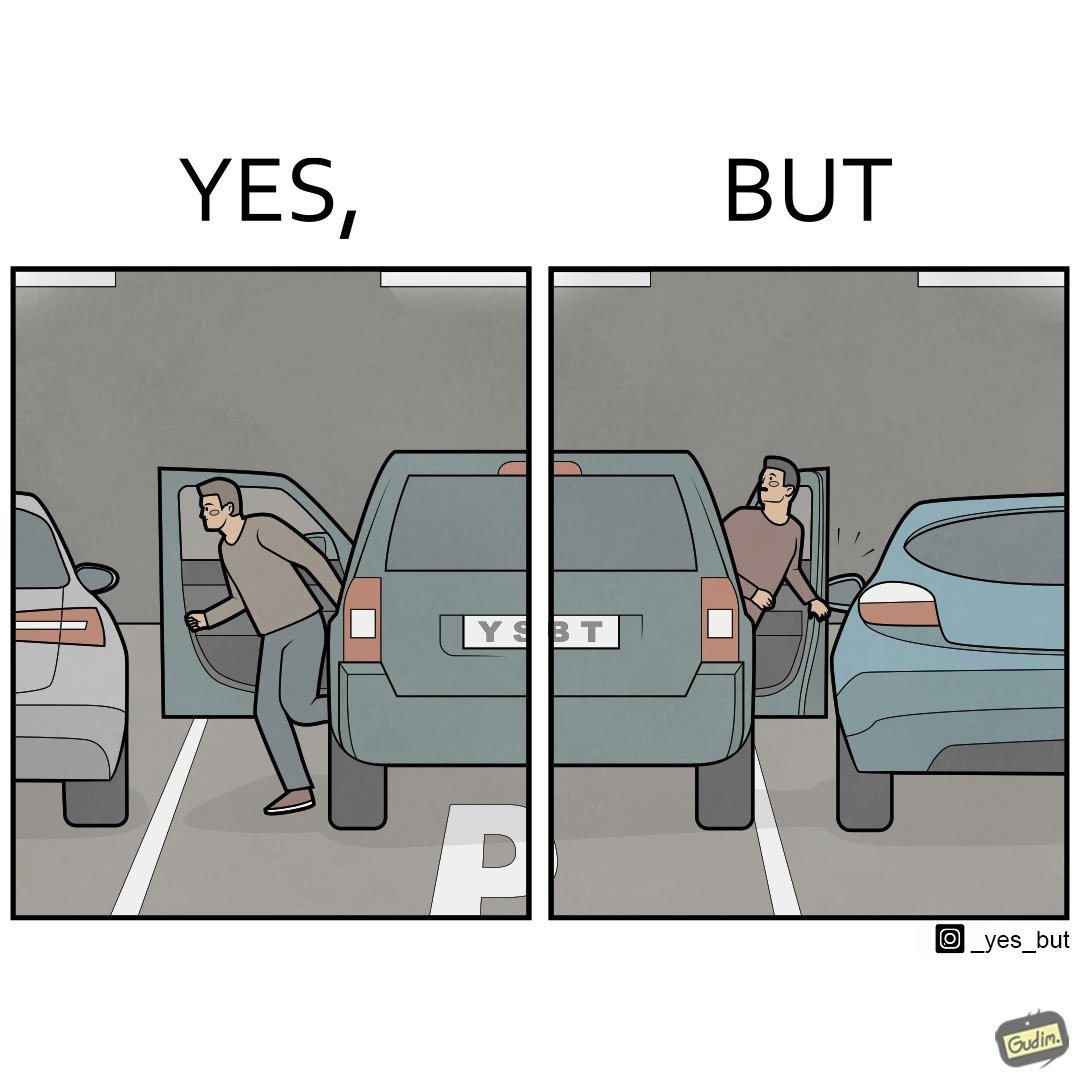Describe the content of this image. The image is ironic, because the left door of the car is easily opened with still space left so the car could have been parked more on the left whereas the right door of the car is getting stuck due to the less space between the two cars and the person in facing difficulty in getting himself out but person on the left easily gets out 